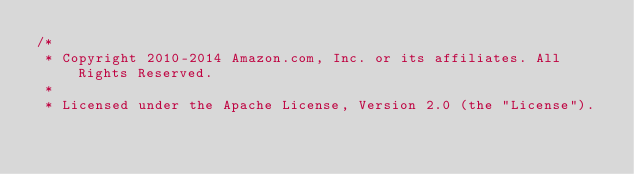Convert code to text. <code><loc_0><loc_0><loc_500><loc_500><_C#_>/*
 * Copyright 2010-2014 Amazon.com, Inc. or its affiliates. All Rights Reserved.
 * 
 * Licensed under the Apache License, Version 2.0 (the "License").</code> 